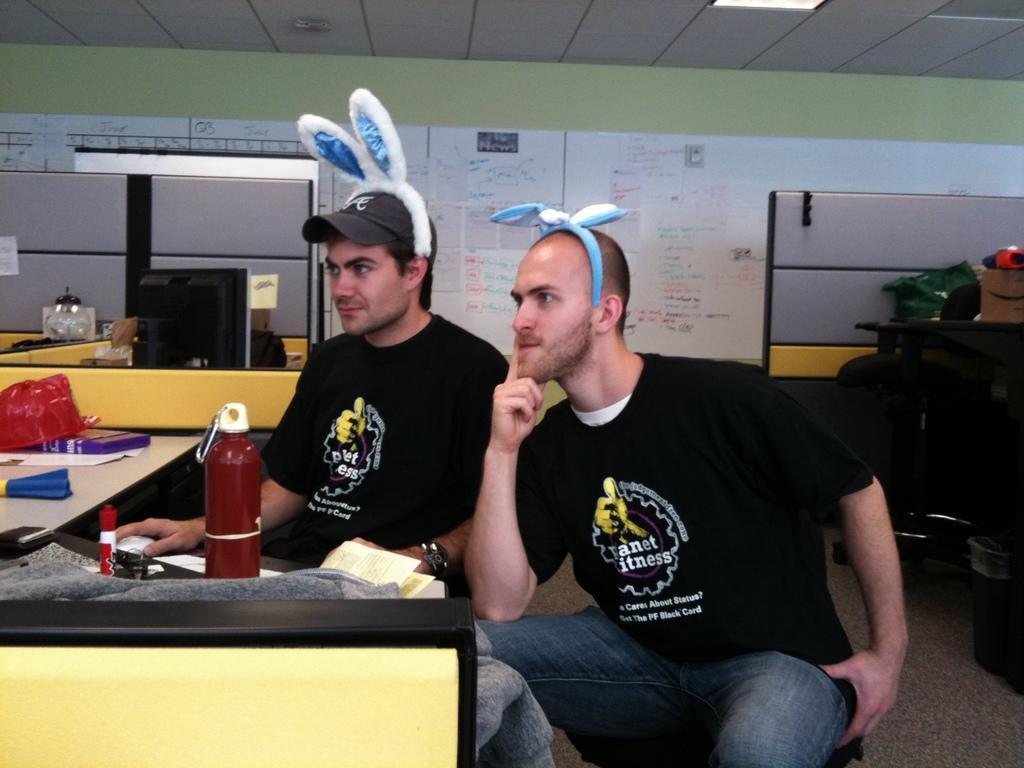Can you describe this image briefly? In this picture we can see two men sitting here, on the left side there is a table, we can see a bottle, a mouse, a cloth, some papers present on the table, in the background there is aboard, we can see some written text here, there is the ceiling at the top of the picture. 